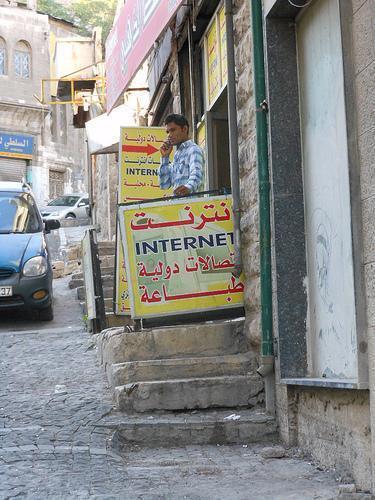How many men?
Give a very brief answer. 1. How many cars?
Give a very brief answer. 2. 